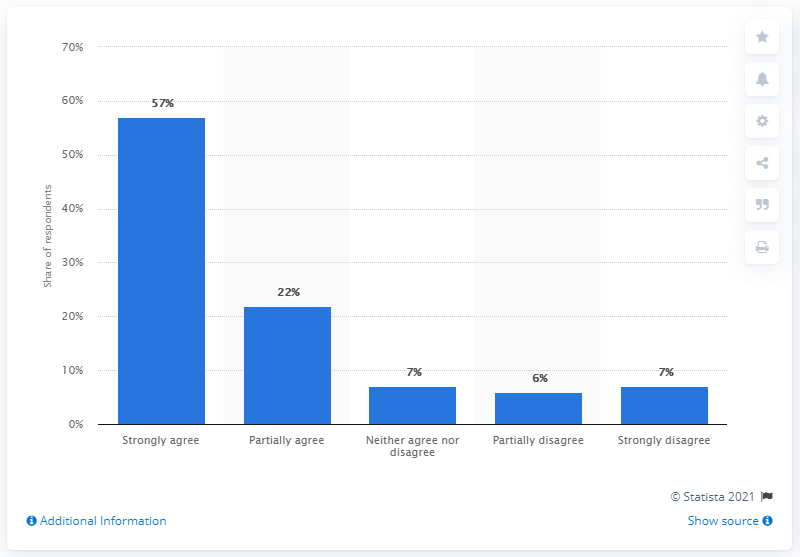Specify some key components in this picture. According to the given information, 57% of Norwegians strongly agreed with the Norwegian government's decision to ban people from going to their holiday homes over Easter. 